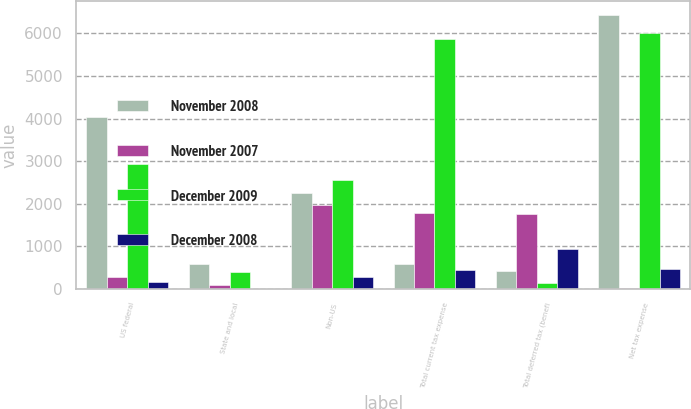Convert chart. <chart><loc_0><loc_0><loc_500><loc_500><stacked_bar_chart><ecel><fcel>US federal<fcel>State and local<fcel>Non-US<fcel>Total current tax expense<fcel>Total deferred tax (benefi<fcel>Net tax expense<nl><fcel>November 2008<fcel>4039<fcel>594<fcel>2242<fcel>594<fcel>431<fcel>6444<nl><fcel>November 2007<fcel>278<fcel>91<fcel>1964<fcel>1777<fcel>1763<fcel>14<nl><fcel>December 2009<fcel>2934<fcel>388<fcel>2554<fcel>5876<fcel>129<fcel>6005<nl><fcel>December 2008<fcel>157<fcel>10<fcel>287<fcel>454<fcel>932<fcel>478<nl></chart> 